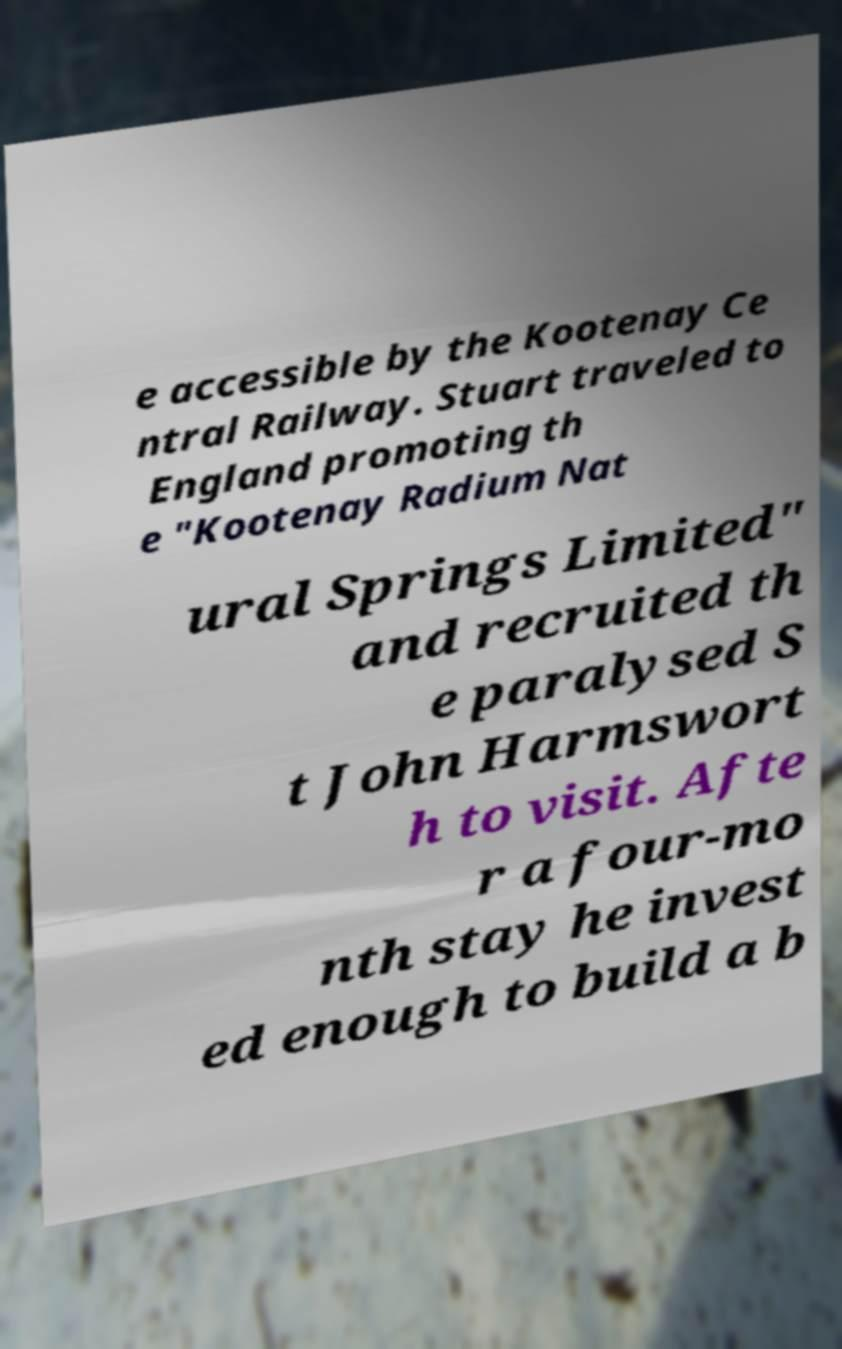I need the written content from this picture converted into text. Can you do that? e accessible by the Kootenay Ce ntral Railway. Stuart traveled to England promoting th e "Kootenay Radium Nat ural Springs Limited" and recruited th e paralysed S t John Harmswort h to visit. Afte r a four-mo nth stay he invest ed enough to build a b 